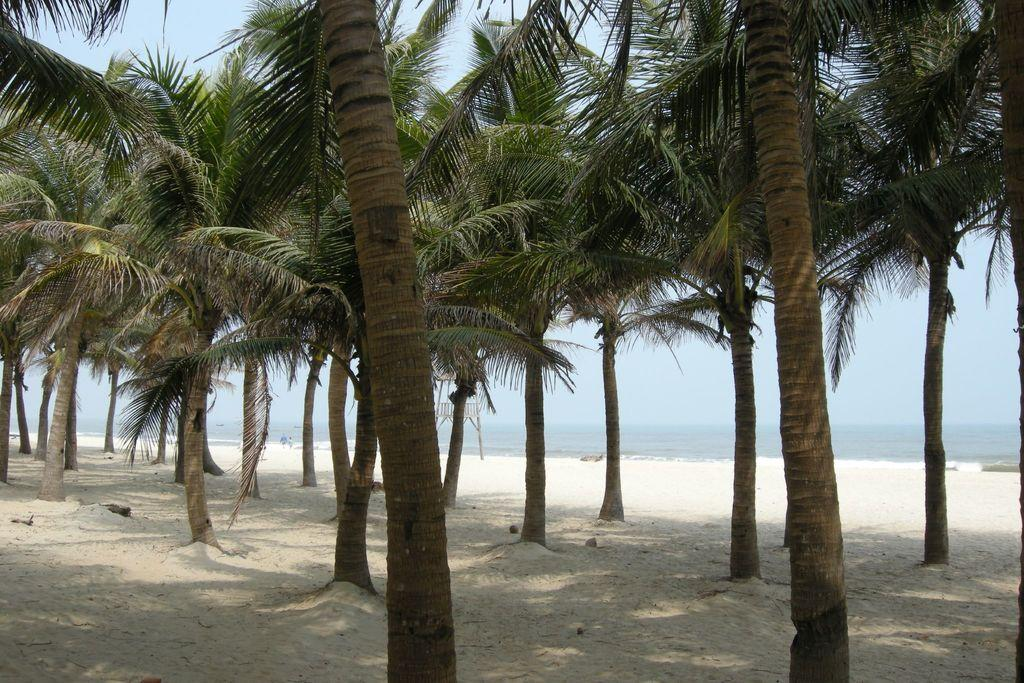What type of vegetation is visible on the ground in the image? There are trees on the ground in the image. What natural element can be seen besides the trees in the image? There is water visible in the image. What is visible in the background of the image? The sky is visible in the background of the image. Can you see any jam on the trees in the image? There is no jam present on the trees in the image. What type of fabric is covering the water in the image? There is no fabric, such as lace, covering the water in the image. 